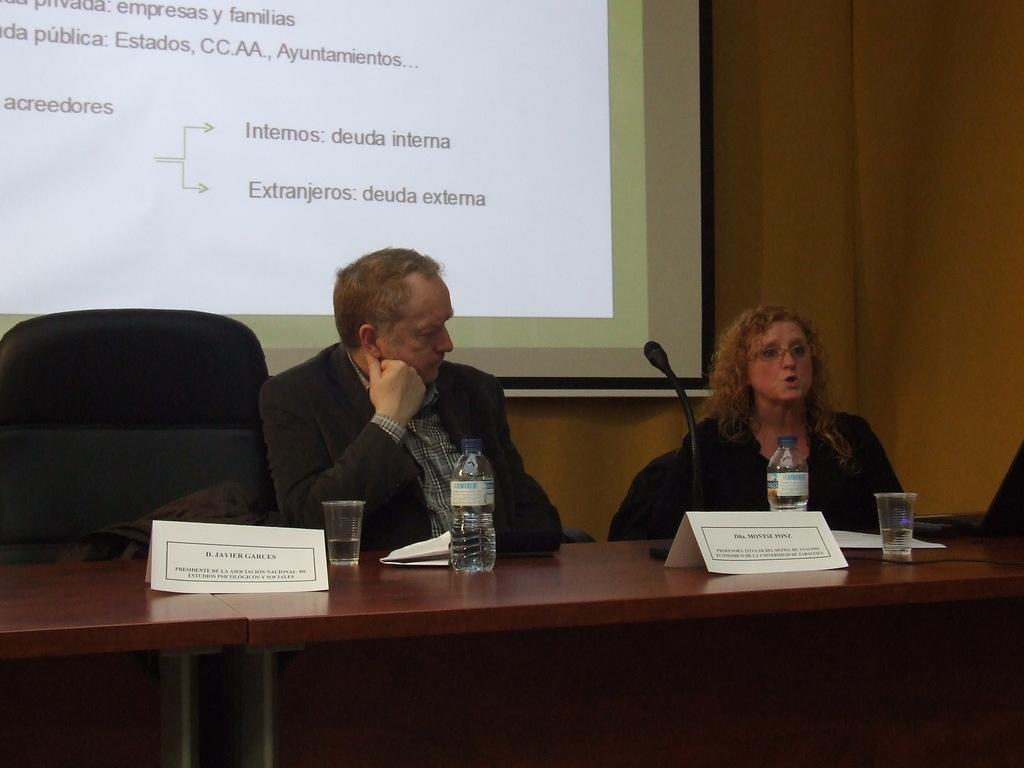Please provide a concise description of this image. In this image in the center there are persons sitting. In the front there is a table on the table there are bottles, glasses and there are banners with some text written on it. In the background there is a screen with some text on it. On the table there is a mic. 